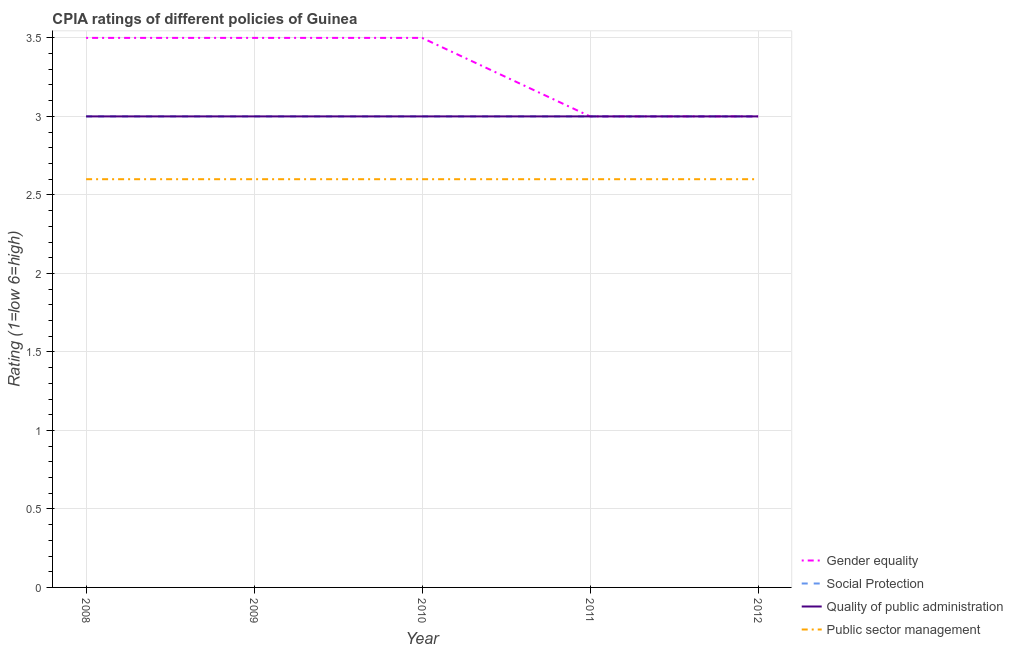How many different coloured lines are there?
Provide a short and direct response. 4. What is the cpia rating of public sector management in 2009?
Your response must be concise. 2.6. Across all years, what is the maximum cpia rating of gender equality?
Your answer should be very brief. 3.5. Across all years, what is the minimum cpia rating of social protection?
Offer a terse response. 3. In which year was the cpia rating of quality of public administration minimum?
Make the answer very short. 2008. What is the total cpia rating of public sector management in the graph?
Your answer should be very brief. 13. What is the difference between the cpia rating of public sector management in 2011 and the cpia rating of social protection in 2012?
Provide a succinct answer. -0.4. In how many years, is the cpia rating of gender equality greater than 1?
Ensure brevity in your answer.  5. Is the difference between the cpia rating of quality of public administration in 2009 and 2011 greater than the difference between the cpia rating of social protection in 2009 and 2011?
Your answer should be compact. No. What is the difference between the highest and the second highest cpia rating of quality of public administration?
Offer a terse response. 0. Is it the case that in every year, the sum of the cpia rating of social protection and cpia rating of gender equality is greater than the sum of cpia rating of public sector management and cpia rating of quality of public administration?
Provide a short and direct response. No. Does the cpia rating of social protection monotonically increase over the years?
Offer a terse response. No. Is the cpia rating of social protection strictly greater than the cpia rating of quality of public administration over the years?
Your answer should be compact. No. Is the cpia rating of public sector management strictly less than the cpia rating of quality of public administration over the years?
Your answer should be very brief. Yes. How many lines are there?
Offer a terse response. 4. How many years are there in the graph?
Your answer should be very brief. 5. What is the difference between two consecutive major ticks on the Y-axis?
Your answer should be very brief. 0.5. Are the values on the major ticks of Y-axis written in scientific E-notation?
Keep it short and to the point. No. Does the graph contain any zero values?
Provide a short and direct response. No. Where does the legend appear in the graph?
Your response must be concise. Bottom right. How many legend labels are there?
Ensure brevity in your answer.  4. How are the legend labels stacked?
Offer a terse response. Vertical. What is the title of the graph?
Offer a very short reply. CPIA ratings of different policies of Guinea. What is the label or title of the X-axis?
Offer a terse response. Year. What is the label or title of the Y-axis?
Keep it short and to the point. Rating (1=low 6=high). What is the Rating (1=low 6=high) in Social Protection in 2008?
Keep it short and to the point. 3. What is the Rating (1=low 6=high) in Quality of public administration in 2008?
Your answer should be very brief. 3. What is the Rating (1=low 6=high) of Public sector management in 2008?
Make the answer very short. 2.6. What is the Rating (1=low 6=high) in Gender equality in 2009?
Give a very brief answer. 3.5. What is the Rating (1=low 6=high) of Quality of public administration in 2009?
Provide a short and direct response. 3. What is the Rating (1=low 6=high) of Gender equality in 2010?
Provide a short and direct response. 3.5. What is the Rating (1=low 6=high) of Quality of public administration in 2010?
Your answer should be very brief. 3. What is the Rating (1=low 6=high) in Public sector management in 2010?
Your answer should be compact. 2.6. What is the Rating (1=low 6=high) of Social Protection in 2011?
Give a very brief answer. 3. What is the Rating (1=low 6=high) in Public sector management in 2011?
Give a very brief answer. 2.6. What is the Rating (1=low 6=high) of Gender equality in 2012?
Give a very brief answer. 3. Across all years, what is the maximum Rating (1=low 6=high) in Gender equality?
Offer a terse response. 3.5. Across all years, what is the maximum Rating (1=low 6=high) in Social Protection?
Provide a short and direct response. 3. Across all years, what is the maximum Rating (1=low 6=high) of Public sector management?
Offer a terse response. 2.6. Across all years, what is the minimum Rating (1=low 6=high) in Social Protection?
Ensure brevity in your answer.  3. Across all years, what is the minimum Rating (1=low 6=high) of Quality of public administration?
Offer a very short reply. 3. Across all years, what is the minimum Rating (1=low 6=high) of Public sector management?
Your answer should be compact. 2.6. What is the total Rating (1=low 6=high) of Gender equality in the graph?
Provide a short and direct response. 16.5. What is the total Rating (1=low 6=high) in Social Protection in the graph?
Make the answer very short. 15. What is the difference between the Rating (1=low 6=high) in Social Protection in 2008 and that in 2010?
Offer a very short reply. 0. What is the difference between the Rating (1=low 6=high) of Public sector management in 2008 and that in 2010?
Provide a short and direct response. 0. What is the difference between the Rating (1=low 6=high) of Gender equality in 2008 and that in 2011?
Provide a succinct answer. 0.5. What is the difference between the Rating (1=low 6=high) in Quality of public administration in 2008 and that in 2012?
Keep it short and to the point. 0. What is the difference between the Rating (1=low 6=high) in Quality of public administration in 2009 and that in 2010?
Provide a succinct answer. 0. What is the difference between the Rating (1=low 6=high) in Public sector management in 2009 and that in 2010?
Make the answer very short. 0. What is the difference between the Rating (1=low 6=high) in Quality of public administration in 2009 and that in 2011?
Keep it short and to the point. 0. What is the difference between the Rating (1=low 6=high) of Quality of public administration in 2009 and that in 2012?
Provide a short and direct response. 0. What is the difference between the Rating (1=low 6=high) in Quality of public administration in 2010 and that in 2011?
Your answer should be compact. 0. What is the difference between the Rating (1=low 6=high) of Public sector management in 2010 and that in 2011?
Offer a very short reply. 0. What is the difference between the Rating (1=low 6=high) of Gender equality in 2010 and that in 2012?
Provide a succinct answer. 0.5. What is the difference between the Rating (1=low 6=high) of Social Protection in 2011 and that in 2012?
Your answer should be very brief. 0. What is the difference between the Rating (1=low 6=high) in Quality of public administration in 2011 and that in 2012?
Offer a terse response. 0. What is the difference between the Rating (1=low 6=high) of Social Protection in 2008 and the Rating (1=low 6=high) of Quality of public administration in 2009?
Provide a succinct answer. 0. What is the difference between the Rating (1=low 6=high) in Social Protection in 2008 and the Rating (1=low 6=high) in Public sector management in 2009?
Keep it short and to the point. 0.4. What is the difference between the Rating (1=low 6=high) of Gender equality in 2008 and the Rating (1=low 6=high) of Public sector management in 2010?
Provide a short and direct response. 0.9. What is the difference between the Rating (1=low 6=high) of Social Protection in 2008 and the Rating (1=low 6=high) of Quality of public administration in 2010?
Offer a terse response. 0. What is the difference between the Rating (1=low 6=high) in Gender equality in 2008 and the Rating (1=low 6=high) in Social Protection in 2011?
Provide a short and direct response. 0.5. What is the difference between the Rating (1=low 6=high) in Gender equality in 2008 and the Rating (1=low 6=high) in Public sector management in 2011?
Give a very brief answer. 0.9. What is the difference between the Rating (1=low 6=high) in Social Protection in 2008 and the Rating (1=low 6=high) in Public sector management in 2011?
Ensure brevity in your answer.  0.4. What is the difference between the Rating (1=low 6=high) of Quality of public administration in 2008 and the Rating (1=low 6=high) of Public sector management in 2011?
Ensure brevity in your answer.  0.4. What is the difference between the Rating (1=low 6=high) of Gender equality in 2008 and the Rating (1=low 6=high) of Public sector management in 2012?
Provide a succinct answer. 0.9. What is the difference between the Rating (1=low 6=high) in Gender equality in 2009 and the Rating (1=low 6=high) in Social Protection in 2010?
Offer a very short reply. 0.5. What is the difference between the Rating (1=low 6=high) of Gender equality in 2009 and the Rating (1=low 6=high) of Quality of public administration in 2010?
Offer a terse response. 0.5. What is the difference between the Rating (1=low 6=high) of Gender equality in 2009 and the Rating (1=low 6=high) of Quality of public administration in 2011?
Your response must be concise. 0.5. What is the difference between the Rating (1=low 6=high) of Gender equality in 2009 and the Rating (1=low 6=high) of Public sector management in 2011?
Your answer should be compact. 0.9. What is the difference between the Rating (1=low 6=high) of Social Protection in 2009 and the Rating (1=low 6=high) of Quality of public administration in 2011?
Give a very brief answer. 0. What is the difference between the Rating (1=low 6=high) of Quality of public administration in 2009 and the Rating (1=low 6=high) of Public sector management in 2011?
Your answer should be very brief. 0.4. What is the difference between the Rating (1=low 6=high) in Gender equality in 2009 and the Rating (1=low 6=high) in Social Protection in 2012?
Offer a terse response. 0.5. What is the difference between the Rating (1=low 6=high) of Social Protection in 2009 and the Rating (1=low 6=high) of Public sector management in 2012?
Your answer should be very brief. 0.4. What is the difference between the Rating (1=low 6=high) of Quality of public administration in 2009 and the Rating (1=low 6=high) of Public sector management in 2012?
Offer a very short reply. 0.4. What is the difference between the Rating (1=low 6=high) in Gender equality in 2010 and the Rating (1=low 6=high) in Social Protection in 2011?
Provide a succinct answer. 0.5. What is the difference between the Rating (1=low 6=high) in Gender equality in 2010 and the Rating (1=low 6=high) in Quality of public administration in 2011?
Keep it short and to the point. 0.5. What is the difference between the Rating (1=low 6=high) in Quality of public administration in 2010 and the Rating (1=low 6=high) in Public sector management in 2011?
Ensure brevity in your answer.  0.4. What is the difference between the Rating (1=low 6=high) in Gender equality in 2010 and the Rating (1=low 6=high) in Quality of public administration in 2012?
Provide a short and direct response. 0.5. What is the difference between the Rating (1=low 6=high) of Social Protection in 2010 and the Rating (1=low 6=high) of Quality of public administration in 2012?
Make the answer very short. 0. What is the difference between the Rating (1=low 6=high) of Social Protection in 2010 and the Rating (1=low 6=high) of Public sector management in 2012?
Offer a terse response. 0.4. What is the difference between the Rating (1=low 6=high) in Quality of public administration in 2010 and the Rating (1=low 6=high) in Public sector management in 2012?
Keep it short and to the point. 0.4. What is the difference between the Rating (1=low 6=high) of Gender equality in 2011 and the Rating (1=low 6=high) of Quality of public administration in 2012?
Keep it short and to the point. 0. What is the difference between the Rating (1=low 6=high) of Social Protection in 2011 and the Rating (1=low 6=high) of Quality of public administration in 2012?
Offer a very short reply. 0. What is the difference between the Rating (1=low 6=high) in Social Protection in 2011 and the Rating (1=low 6=high) in Public sector management in 2012?
Offer a terse response. 0.4. What is the average Rating (1=low 6=high) in Gender equality per year?
Give a very brief answer. 3.3. What is the average Rating (1=low 6=high) in Quality of public administration per year?
Provide a succinct answer. 3. What is the average Rating (1=low 6=high) in Public sector management per year?
Offer a very short reply. 2.6. In the year 2008, what is the difference between the Rating (1=low 6=high) of Gender equality and Rating (1=low 6=high) of Social Protection?
Provide a short and direct response. 0.5. In the year 2008, what is the difference between the Rating (1=low 6=high) of Gender equality and Rating (1=low 6=high) of Quality of public administration?
Make the answer very short. 0.5. In the year 2008, what is the difference between the Rating (1=low 6=high) of Social Protection and Rating (1=low 6=high) of Quality of public administration?
Your response must be concise. 0. In the year 2008, what is the difference between the Rating (1=low 6=high) of Quality of public administration and Rating (1=low 6=high) of Public sector management?
Offer a terse response. 0.4. In the year 2009, what is the difference between the Rating (1=low 6=high) of Quality of public administration and Rating (1=low 6=high) of Public sector management?
Ensure brevity in your answer.  0.4. In the year 2010, what is the difference between the Rating (1=low 6=high) of Gender equality and Rating (1=low 6=high) of Social Protection?
Your answer should be very brief. 0.5. In the year 2010, what is the difference between the Rating (1=low 6=high) of Gender equality and Rating (1=low 6=high) of Quality of public administration?
Offer a very short reply. 0.5. In the year 2010, what is the difference between the Rating (1=low 6=high) of Gender equality and Rating (1=low 6=high) of Public sector management?
Make the answer very short. 0.9. In the year 2010, what is the difference between the Rating (1=low 6=high) of Quality of public administration and Rating (1=low 6=high) of Public sector management?
Your response must be concise. 0.4. In the year 2011, what is the difference between the Rating (1=low 6=high) in Gender equality and Rating (1=low 6=high) in Social Protection?
Your answer should be very brief. 0. In the year 2011, what is the difference between the Rating (1=low 6=high) in Gender equality and Rating (1=low 6=high) in Quality of public administration?
Offer a very short reply. 0. In the year 2011, what is the difference between the Rating (1=low 6=high) in Gender equality and Rating (1=low 6=high) in Public sector management?
Your answer should be very brief. 0.4. In the year 2011, what is the difference between the Rating (1=low 6=high) in Social Protection and Rating (1=low 6=high) in Public sector management?
Offer a very short reply. 0.4. In the year 2012, what is the difference between the Rating (1=low 6=high) of Gender equality and Rating (1=low 6=high) of Social Protection?
Provide a short and direct response. 0. In the year 2012, what is the difference between the Rating (1=low 6=high) of Gender equality and Rating (1=low 6=high) of Quality of public administration?
Give a very brief answer. 0. In the year 2012, what is the difference between the Rating (1=low 6=high) of Gender equality and Rating (1=low 6=high) of Public sector management?
Provide a succinct answer. 0.4. In the year 2012, what is the difference between the Rating (1=low 6=high) in Social Protection and Rating (1=low 6=high) in Quality of public administration?
Offer a terse response. 0. In the year 2012, what is the difference between the Rating (1=low 6=high) of Quality of public administration and Rating (1=low 6=high) of Public sector management?
Offer a terse response. 0.4. What is the ratio of the Rating (1=low 6=high) of Gender equality in 2008 to that in 2009?
Give a very brief answer. 1. What is the ratio of the Rating (1=low 6=high) of Gender equality in 2008 to that in 2010?
Your answer should be very brief. 1. What is the ratio of the Rating (1=low 6=high) in Quality of public administration in 2008 to that in 2011?
Your answer should be very brief. 1. What is the ratio of the Rating (1=low 6=high) of Public sector management in 2008 to that in 2011?
Give a very brief answer. 1. What is the ratio of the Rating (1=low 6=high) in Gender equality in 2008 to that in 2012?
Offer a terse response. 1.17. What is the ratio of the Rating (1=low 6=high) in Social Protection in 2008 to that in 2012?
Offer a very short reply. 1. What is the ratio of the Rating (1=low 6=high) of Social Protection in 2009 to that in 2010?
Offer a very short reply. 1. What is the ratio of the Rating (1=low 6=high) in Gender equality in 2009 to that in 2011?
Give a very brief answer. 1.17. What is the ratio of the Rating (1=low 6=high) of Public sector management in 2009 to that in 2011?
Keep it short and to the point. 1. What is the ratio of the Rating (1=low 6=high) of Gender equality in 2009 to that in 2012?
Your response must be concise. 1.17. What is the ratio of the Rating (1=low 6=high) of Social Protection in 2009 to that in 2012?
Keep it short and to the point. 1. What is the ratio of the Rating (1=low 6=high) of Quality of public administration in 2009 to that in 2012?
Your answer should be very brief. 1. What is the ratio of the Rating (1=low 6=high) in Public sector management in 2009 to that in 2012?
Your answer should be very brief. 1. What is the ratio of the Rating (1=low 6=high) in Gender equality in 2010 to that in 2011?
Provide a succinct answer. 1.17. What is the ratio of the Rating (1=low 6=high) in Social Protection in 2010 to that in 2011?
Offer a terse response. 1. What is the ratio of the Rating (1=low 6=high) of Public sector management in 2010 to that in 2011?
Ensure brevity in your answer.  1. What is the ratio of the Rating (1=low 6=high) of Gender equality in 2010 to that in 2012?
Your answer should be compact. 1.17. What is the ratio of the Rating (1=low 6=high) in Gender equality in 2011 to that in 2012?
Your answer should be very brief. 1. What is the difference between the highest and the second highest Rating (1=low 6=high) in Social Protection?
Provide a succinct answer. 0. What is the difference between the highest and the second highest Rating (1=low 6=high) in Quality of public administration?
Keep it short and to the point. 0. What is the difference between the highest and the second highest Rating (1=low 6=high) in Public sector management?
Keep it short and to the point. 0. What is the difference between the highest and the lowest Rating (1=low 6=high) in Gender equality?
Keep it short and to the point. 0.5. What is the difference between the highest and the lowest Rating (1=low 6=high) in Social Protection?
Your response must be concise. 0. What is the difference between the highest and the lowest Rating (1=low 6=high) in Quality of public administration?
Give a very brief answer. 0. What is the difference between the highest and the lowest Rating (1=low 6=high) of Public sector management?
Provide a succinct answer. 0. 